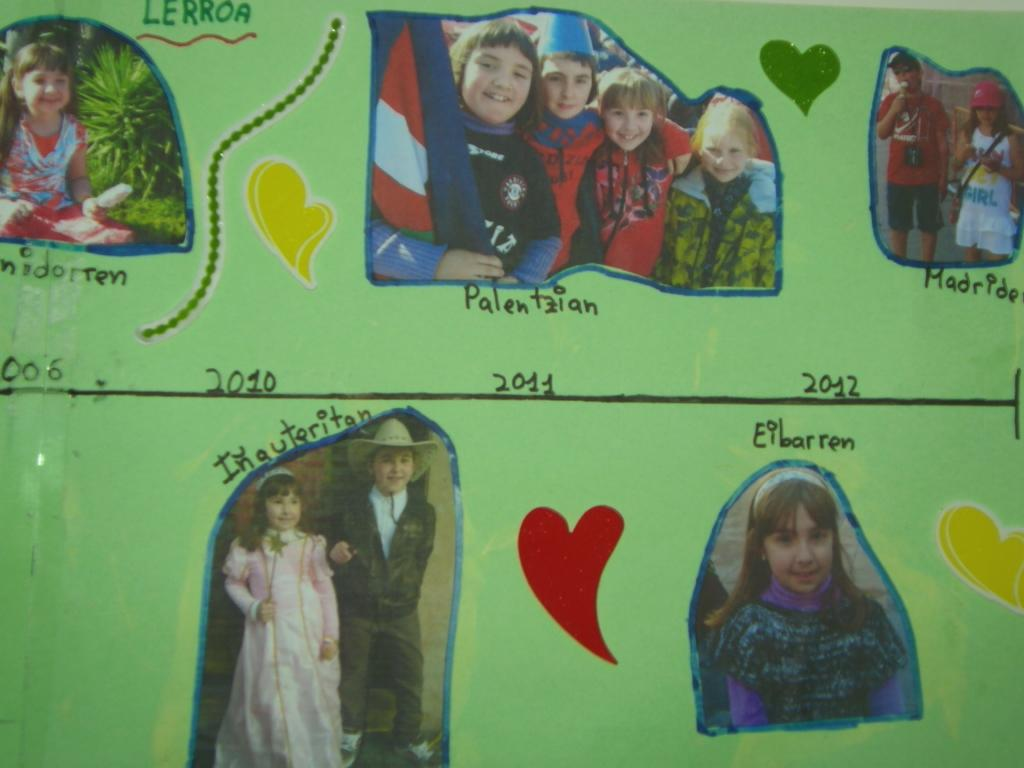What is the color of the wall in the image? The wall in the image is green. What is placed on the green wall? Photos of children are placed on the wall. Are there any other features on the wall besides the photos? Yes, there are posts on the wall. Is there any writing on the wall? Yes, text is written on the wall. What type of tax is mentioned on the wall in the image? There is no mention of tax in the image; the text on the wall is unrelated to taxes. 